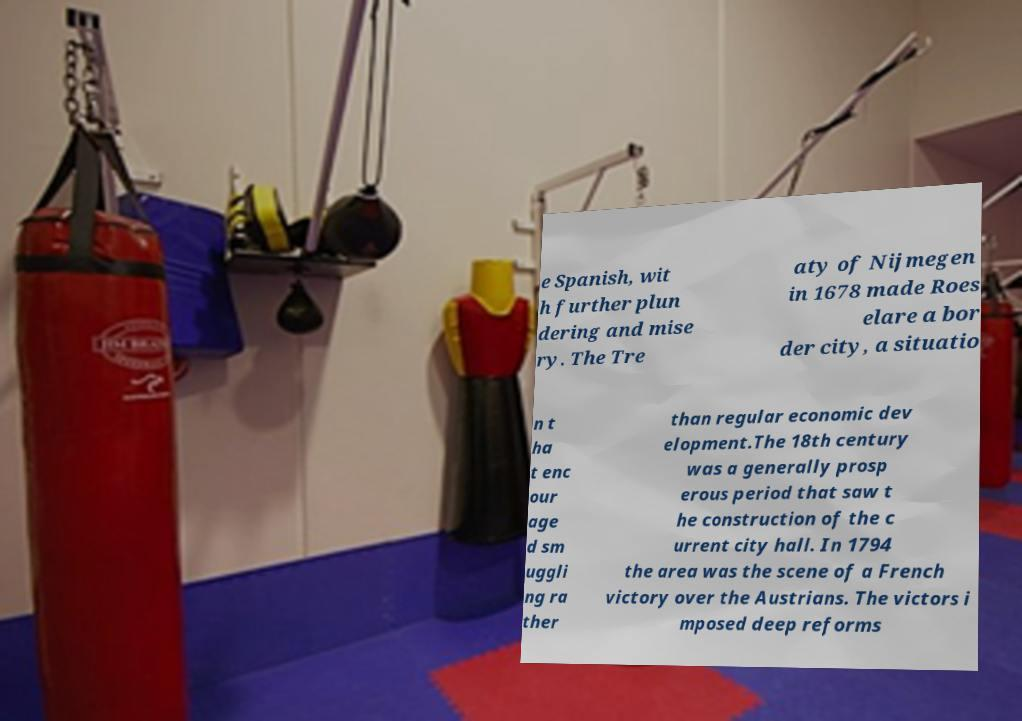There's text embedded in this image that I need extracted. Can you transcribe it verbatim? e Spanish, wit h further plun dering and mise ry. The Tre aty of Nijmegen in 1678 made Roes elare a bor der city, a situatio n t ha t enc our age d sm uggli ng ra ther than regular economic dev elopment.The 18th century was a generally prosp erous period that saw t he construction of the c urrent city hall. In 1794 the area was the scene of a French victory over the Austrians. The victors i mposed deep reforms 